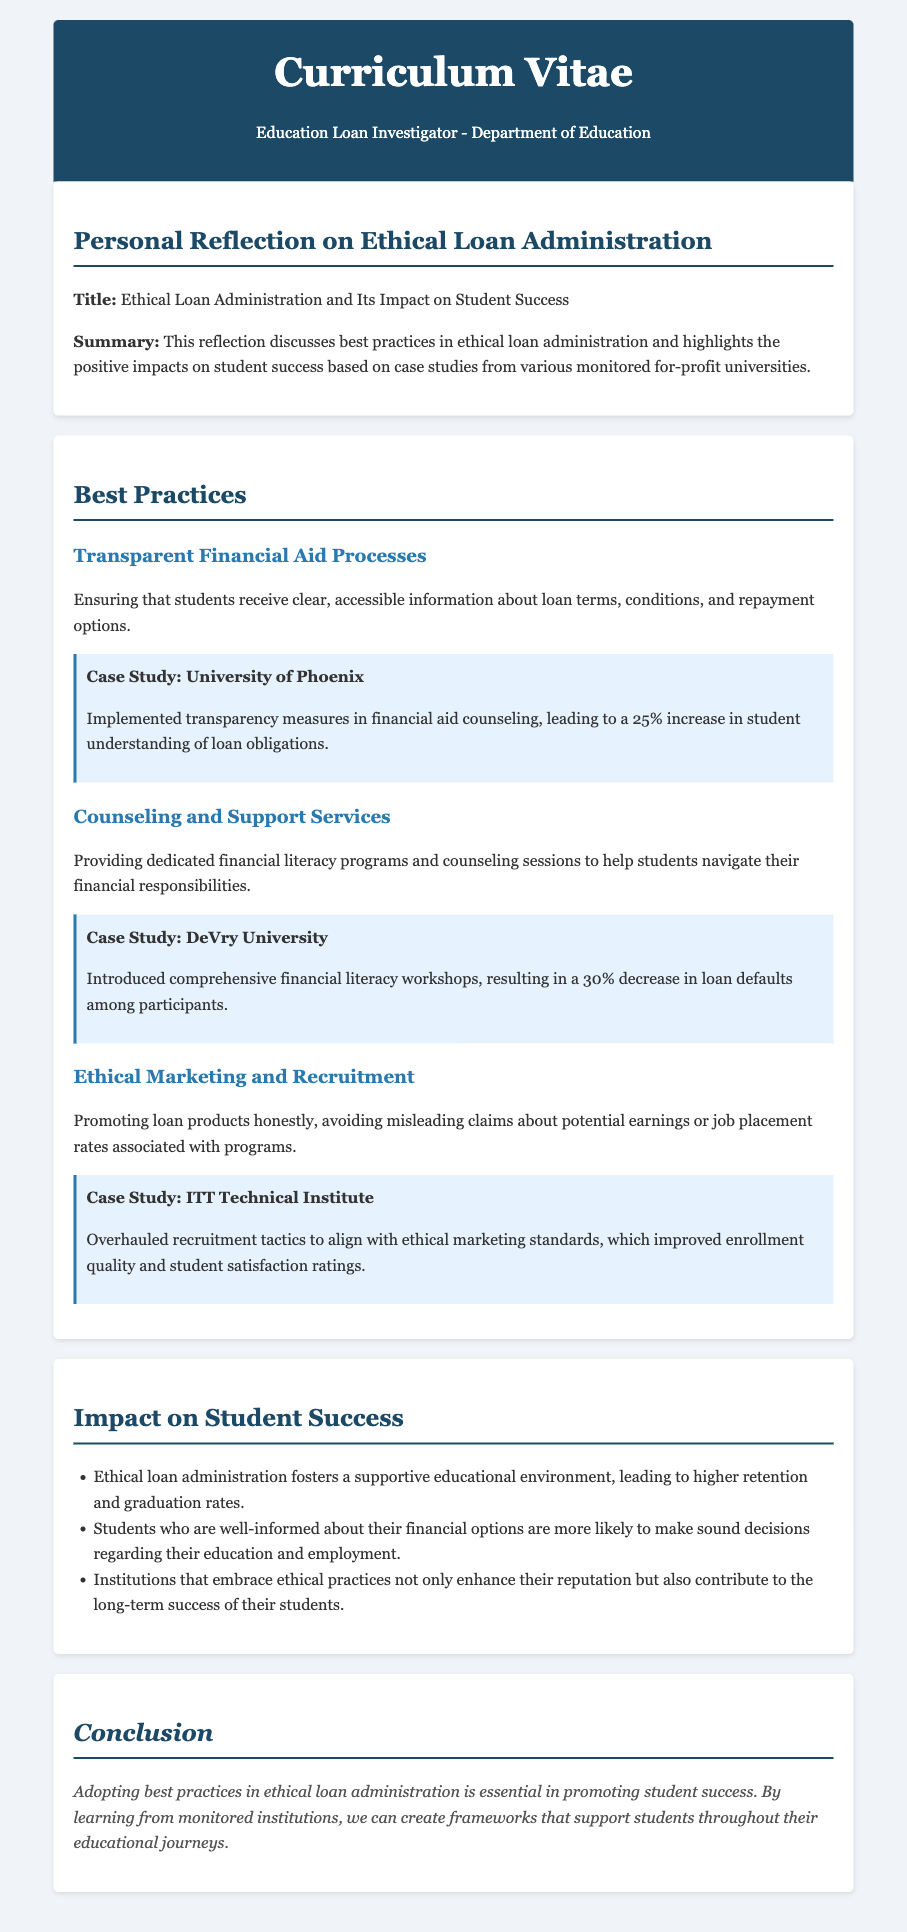What is the title of the reflection? The title is prominently displayed under the section on ethical loan administration.
Answer: Ethical Loan Administration and Its Impact on Student Success Which university implemented transparency measures in financial aid counseling? The university associated with the case study is mentioned right after the explanation of best practices.
Answer: University of Phoenix What percentage increase in student understanding of loan obligations was achieved at the University of Phoenix? The document specifies that a certain percentage increase was reported in the case study.
Answer: 25% What was the percentage decrease in loan defaults among participants at DeVry University? This statistic is found in the case study related to comprehensive financial literacy workshops.
Answer: 30% What type of workshops did DeVry University introduce? The specific type of educational initiative is specified in the section discussing counseling and support services.
Answer: Financial literacy workshops What unethical practice does the document suggest to avoid in marketing? This concept is addressed in the section focused on ethical marketing and recruitment.
Answer: Misleading claims What improvement was noted at ITT Technical Institute after overhauling recruitment tactics? The result of the changes in recruitment practices is stated in the case study of this institution.
Answer: Improved enrollment quality and student satisfaction ratings What impact does ethical loan administration have on retention and graduation rates? This outcome is mentioned in the impact section of the document.
Answer: Higher retention and graduation rates 